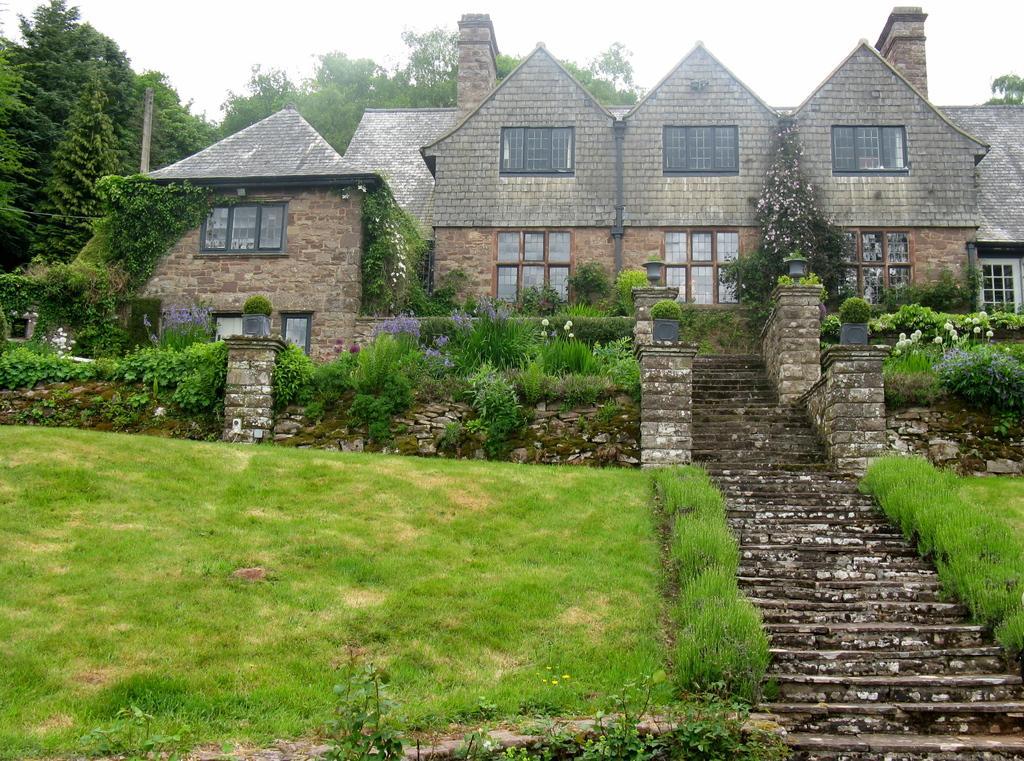In one or two sentences, can you explain what this image depicts? In this image we can see some plants, grass, stairs and in the background of the image there are some houses and clear sky. 